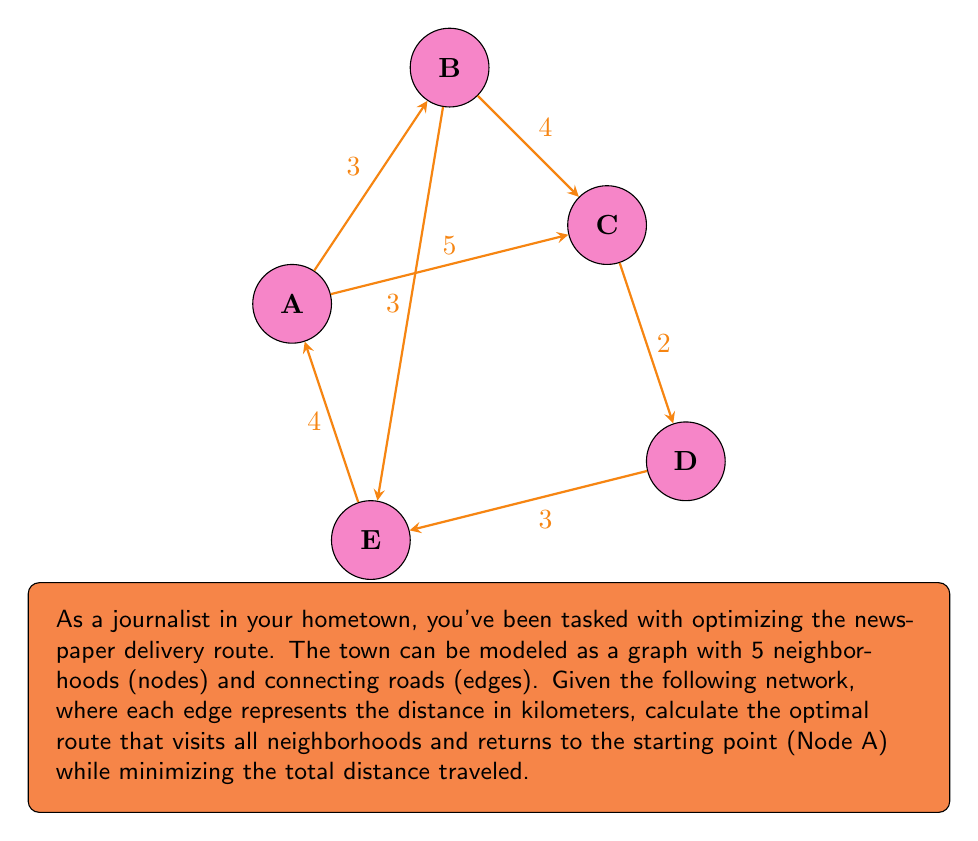Could you help me with this problem? To solve this problem, we'll use the concept of the Traveling Salesman Problem (TSP) in graph theory, which is a classic optimization problem in topology.

Step 1: Identify all possible routes.
With 5 nodes, there are (5-1)! = 24 possible routes.

Step 2: Calculate the distance for each route.
Let's consider a few examples:
A-B-C-D-E-A: 3 + 4 + 2 + 3 + 4 = 16 km
A-C-B-E-D-A: 5 + 4 + 3 + 3 + 5 = 20 km
A-E-D-C-B-A: 4 + 3 + 2 + 4 + 3 = 16 km

Step 3: Identify the shortest route.
After calculating all routes, we find that A-B-C-D-E-A and A-E-D-C-B-A both have the minimum distance of 16 km.

Step 4: Verify the optimality.
We can confirm that 16 km is indeed the shortest possible route by checking that no other combination of edges can produce a shorter total distance while visiting all nodes.

Step 5: Express the solution mathematically.
Let $G = (V, E)$ be our graph, where $V = \{A, B, C, D, E\}$ and $E$ represents the edges with their respective weights. The optimal route $R$ can be expressed as:

$$R = \arg\min_{p \in P} \sum_{i=1}^{n} d(v_i, v_{i+1})$$

Where $P$ is the set of all possible Hamiltonian cycles, $n$ is the number of nodes, $v_i$ are the nodes in the order they are visited, and $d(v_i, v_{i+1})$ is the distance between consecutive nodes in the cycle.
Answer: 16 km (A-B-C-D-E-A or A-E-D-C-B-A) 